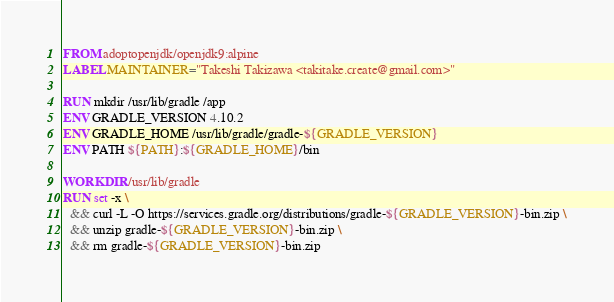Convert code to text. <code><loc_0><loc_0><loc_500><loc_500><_Dockerfile_>FROM adoptopenjdk/openjdk9:alpine
LABEL MAINTAINER="Takeshi Takizawa <takitake.create@gmail.com>"

RUN mkdir /usr/lib/gradle /app
ENV GRADLE_VERSION 4.10.2
ENV GRADLE_HOME /usr/lib/gradle/gradle-${GRADLE_VERSION}
ENV PATH ${PATH}:${GRADLE_HOME}/bin

WORKDIR /usr/lib/gradle
RUN set -x \
  && curl -L -O https://services.gradle.org/distributions/gradle-${GRADLE_VERSION}-bin.zip \
  && unzip gradle-${GRADLE_VERSION}-bin.zip \
  && rm gradle-${GRADLE_VERSION}-bin.zip
</code> 